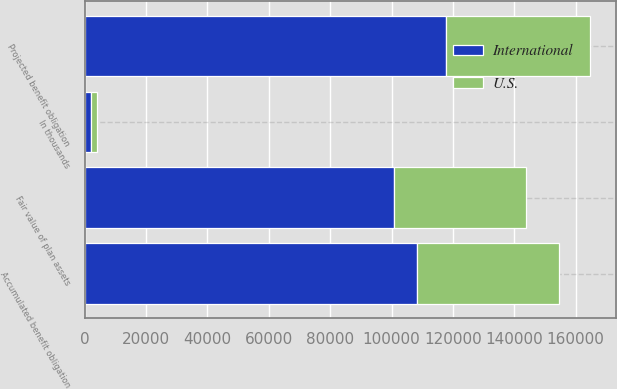<chart> <loc_0><loc_0><loc_500><loc_500><stacked_bar_chart><ecel><fcel>In thousands<fcel>Projected benefit obligation<fcel>Accumulated benefit obligation<fcel>Fair value of plan assets<nl><fcel>U.S.<fcel>2013<fcel>47090<fcel>46316<fcel>42980<nl><fcel>International<fcel>2013<fcel>117717<fcel>108182<fcel>100798<nl></chart> 